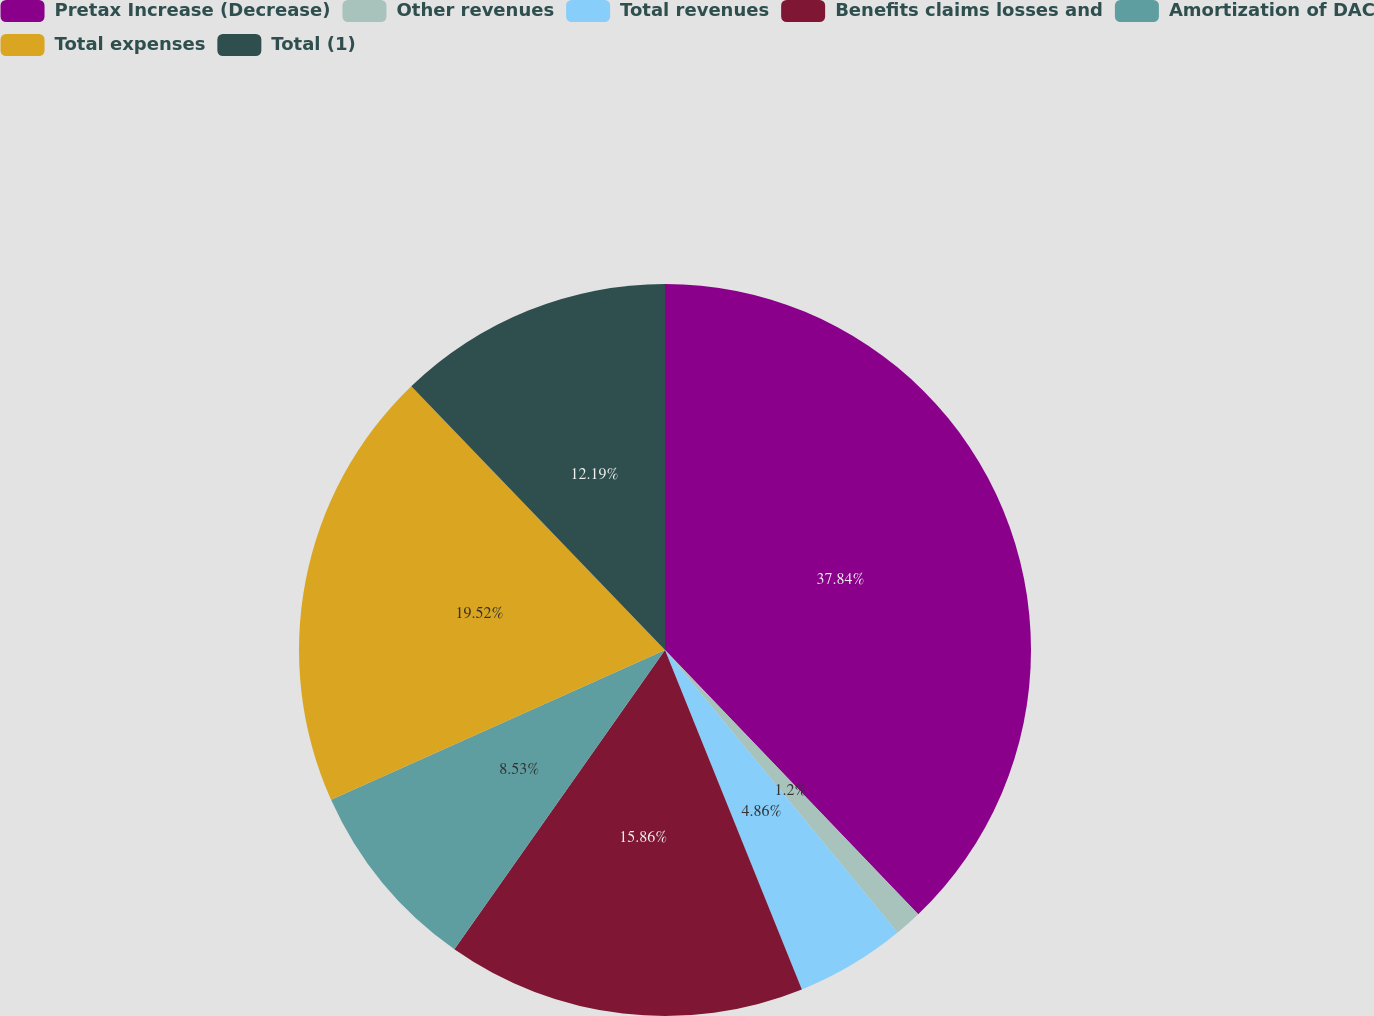Convert chart. <chart><loc_0><loc_0><loc_500><loc_500><pie_chart><fcel>Pretax Increase (Decrease)<fcel>Other revenues<fcel>Total revenues<fcel>Benefits claims losses and<fcel>Amortization of DAC<fcel>Total expenses<fcel>Total (1)<nl><fcel>37.84%<fcel>1.2%<fcel>4.86%<fcel>15.86%<fcel>8.53%<fcel>19.52%<fcel>12.19%<nl></chart> 